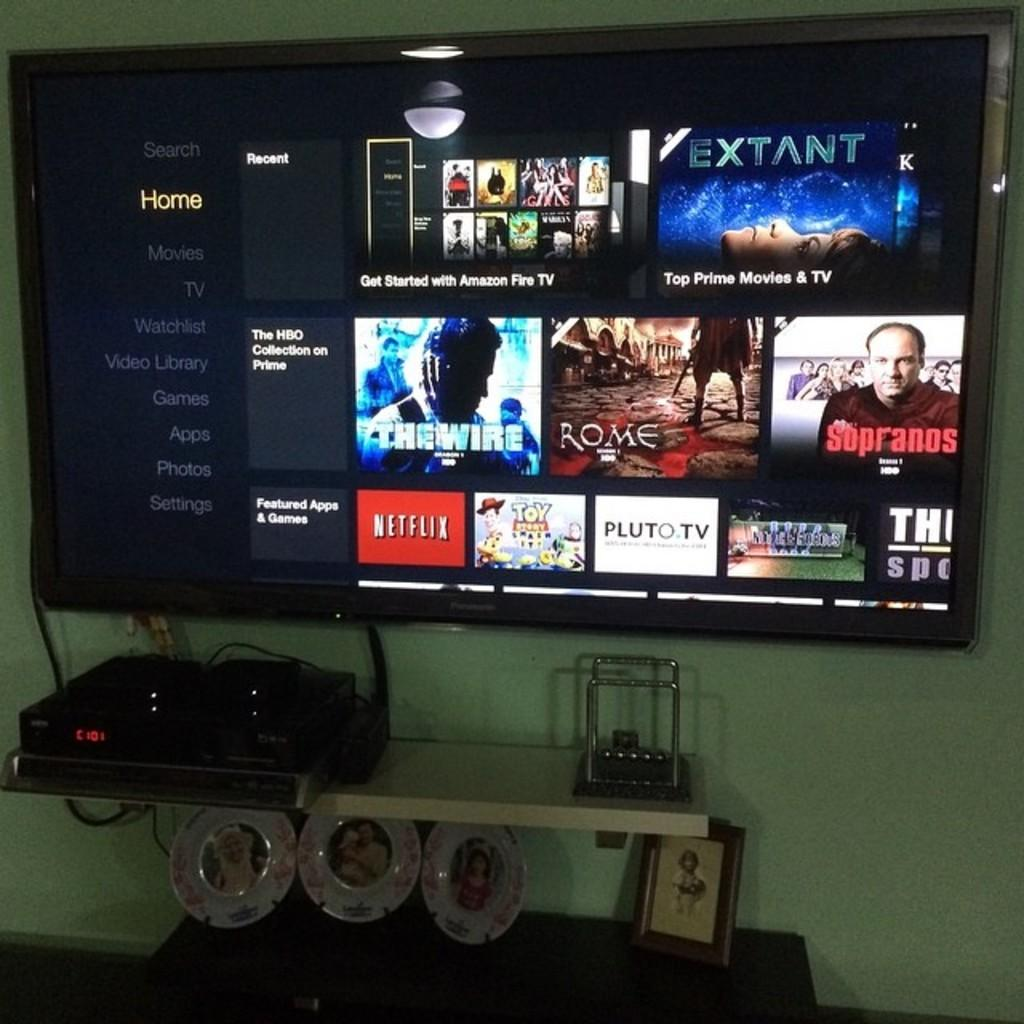Provide a one-sentence caption for the provided image. a flat screen tv displaying shows from netflix and the sopranos. 